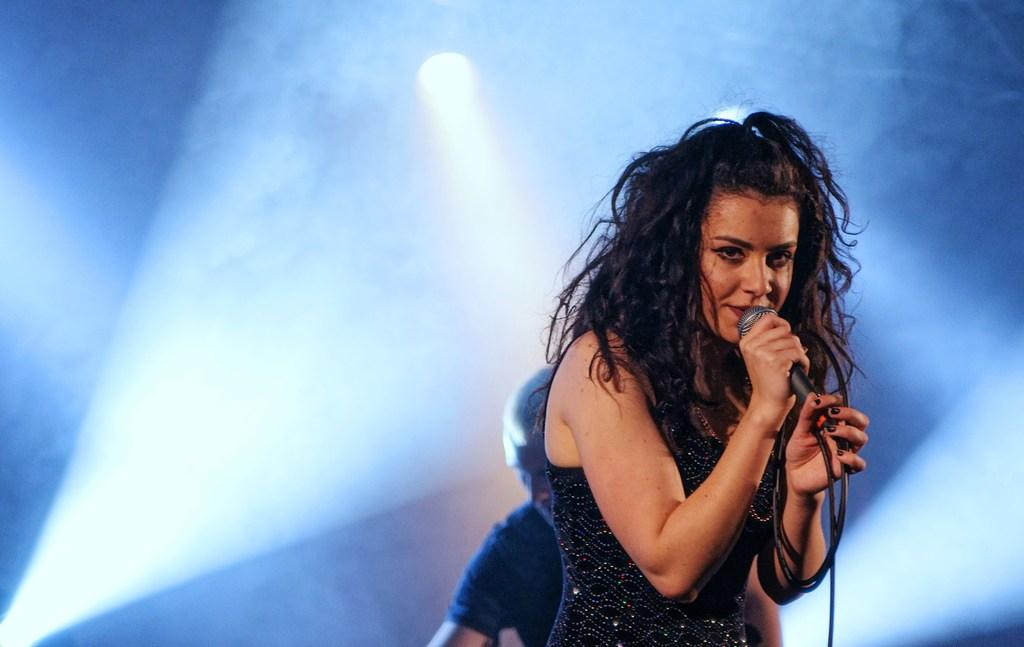Who is the main subject in the image? There is a woman in the image. What is the woman holding in her hand? The woman is holding a microphone in her hand. What color is the top that the woman is wearing? The woman is wearing a black top. What can be seen behind the woman in the image? There is a light visible behind the woman. What type of grape is the woman eating in the image? There is no grape present in the image, and the woman is not eating anything. Is the woman wearing a mask in the image? No, the woman is not wearing a mask in the image. 